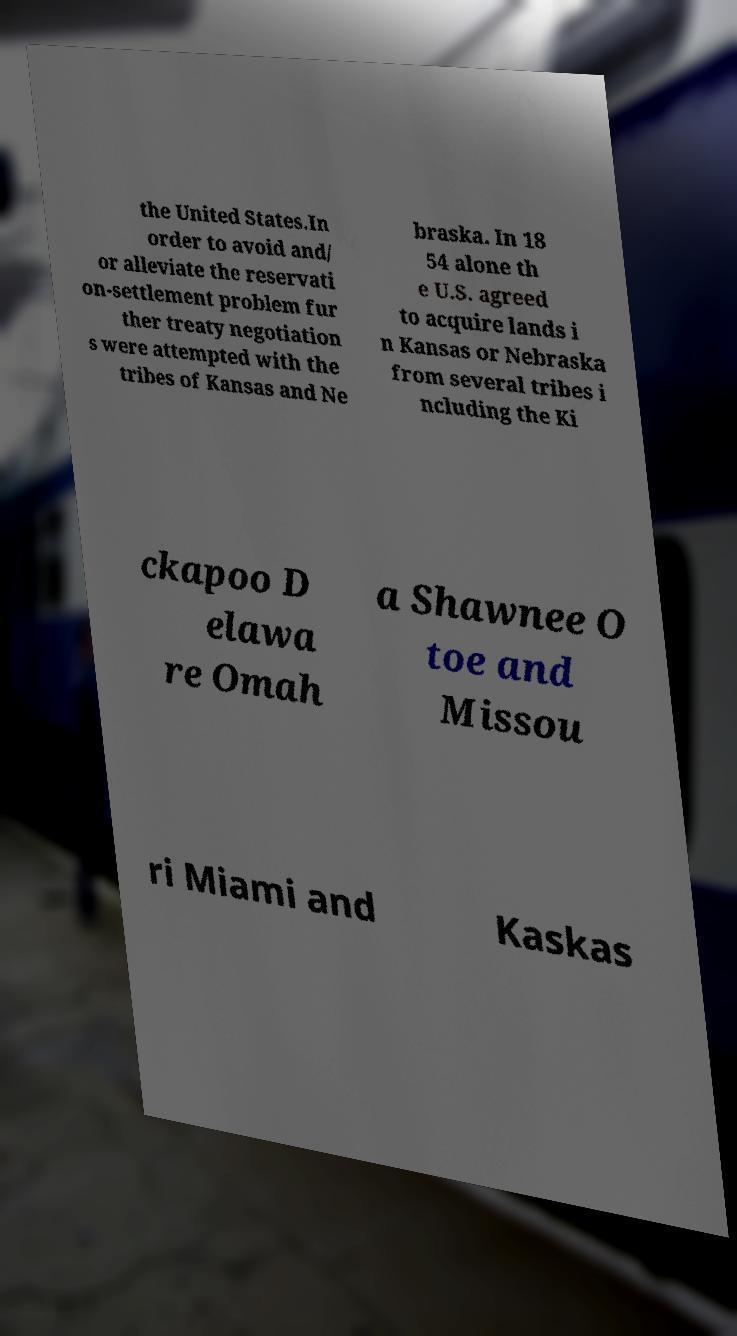Can you accurately transcribe the text from the provided image for me? the United States.In order to avoid and/ or alleviate the reservati on-settlement problem fur ther treaty negotiation s were attempted with the tribes of Kansas and Ne braska. In 18 54 alone th e U.S. agreed to acquire lands i n Kansas or Nebraska from several tribes i ncluding the Ki ckapoo D elawa re Omah a Shawnee O toe and Missou ri Miami and Kaskas 